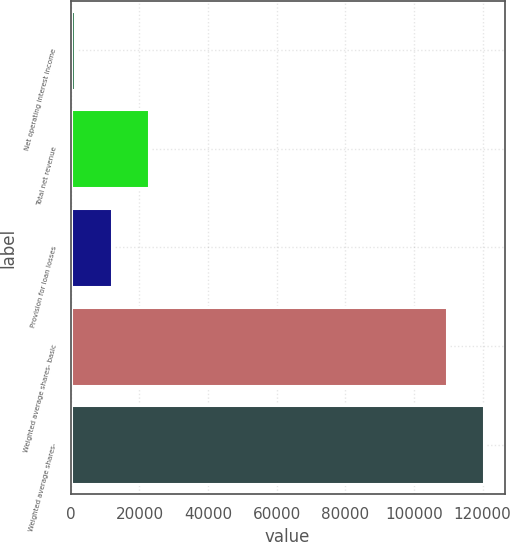Convert chart to OTSL. <chart><loc_0><loc_0><loc_500><loc_500><bar_chart><fcel>Net operating interest income<fcel>Total net revenue<fcel>Provision for loan losses<fcel>Weighted average shares- basic<fcel>Weighted average shares-<nl><fcel>1260.6<fcel>22917.3<fcel>12088.9<fcel>109544<fcel>120372<nl></chart> 